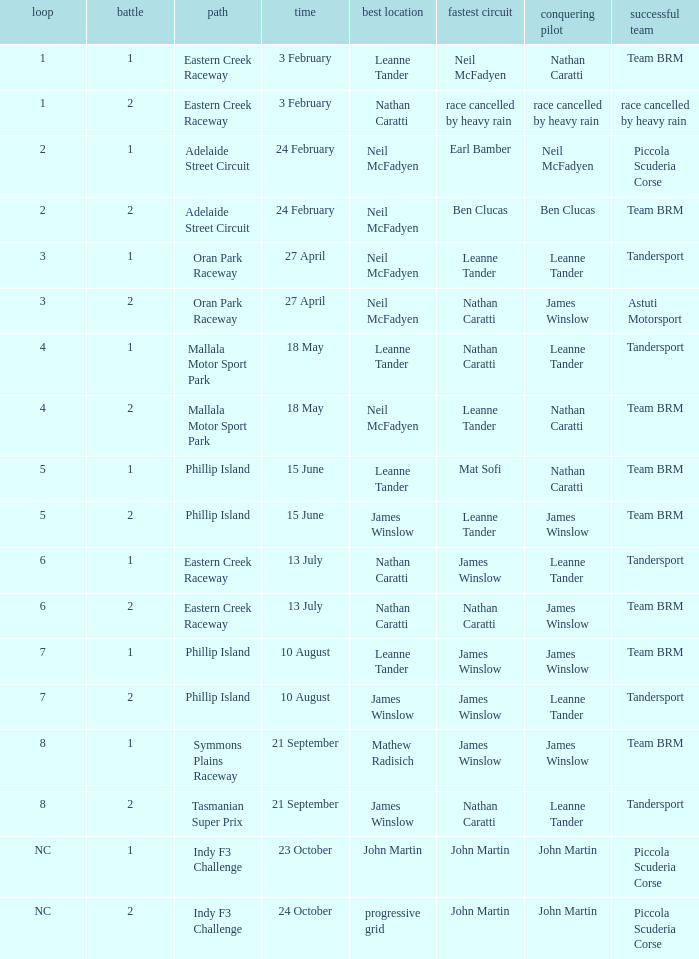Which race number in the Indy F3 Challenge circuit had John Martin in pole position? 1.0. Would you be able to parse every entry in this table? {'header': ['loop', 'battle', 'path', 'time', 'best location', 'fastest circuit', 'conquering pilot', 'successful team'], 'rows': [['1', '1', 'Eastern Creek Raceway', '3 February', 'Leanne Tander', 'Neil McFadyen', 'Nathan Caratti', 'Team BRM'], ['1', '2', 'Eastern Creek Raceway', '3 February', 'Nathan Caratti', 'race cancelled by heavy rain', 'race cancelled by heavy rain', 'race cancelled by heavy rain'], ['2', '1', 'Adelaide Street Circuit', '24 February', 'Neil McFadyen', 'Earl Bamber', 'Neil McFadyen', 'Piccola Scuderia Corse'], ['2', '2', 'Adelaide Street Circuit', '24 February', 'Neil McFadyen', 'Ben Clucas', 'Ben Clucas', 'Team BRM'], ['3', '1', 'Oran Park Raceway', '27 April', 'Neil McFadyen', 'Leanne Tander', 'Leanne Tander', 'Tandersport'], ['3', '2', 'Oran Park Raceway', '27 April', 'Neil McFadyen', 'Nathan Caratti', 'James Winslow', 'Astuti Motorsport'], ['4', '1', 'Mallala Motor Sport Park', '18 May', 'Leanne Tander', 'Nathan Caratti', 'Leanne Tander', 'Tandersport'], ['4', '2', 'Mallala Motor Sport Park', '18 May', 'Neil McFadyen', 'Leanne Tander', 'Nathan Caratti', 'Team BRM'], ['5', '1', 'Phillip Island', '15 June', 'Leanne Tander', 'Mat Sofi', 'Nathan Caratti', 'Team BRM'], ['5', '2', 'Phillip Island', '15 June', 'James Winslow', 'Leanne Tander', 'James Winslow', 'Team BRM'], ['6', '1', 'Eastern Creek Raceway', '13 July', 'Nathan Caratti', 'James Winslow', 'Leanne Tander', 'Tandersport'], ['6', '2', 'Eastern Creek Raceway', '13 July', 'Nathan Caratti', 'Nathan Caratti', 'James Winslow', 'Team BRM'], ['7', '1', 'Phillip Island', '10 August', 'Leanne Tander', 'James Winslow', 'James Winslow', 'Team BRM'], ['7', '2', 'Phillip Island', '10 August', 'James Winslow', 'James Winslow', 'Leanne Tander', 'Tandersport'], ['8', '1', 'Symmons Plains Raceway', '21 September', 'Mathew Radisich', 'James Winslow', 'James Winslow', 'Team BRM'], ['8', '2', 'Tasmanian Super Prix', '21 September', 'James Winslow', 'Nathan Caratti', 'Leanne Tander', 'Tandersport'], ['NC', '1', 'Indy F3 Challenge', '23 October', 'John Martin', 'John Martin', 'John Martin', 'Piccola Scuderia Corse'], ['NC', '2', 'Indy F3 Challenge', '24 October', 'progressive grid', 'John Martin', 'John Martin', 'Piccola Scuderia Corse']]} 